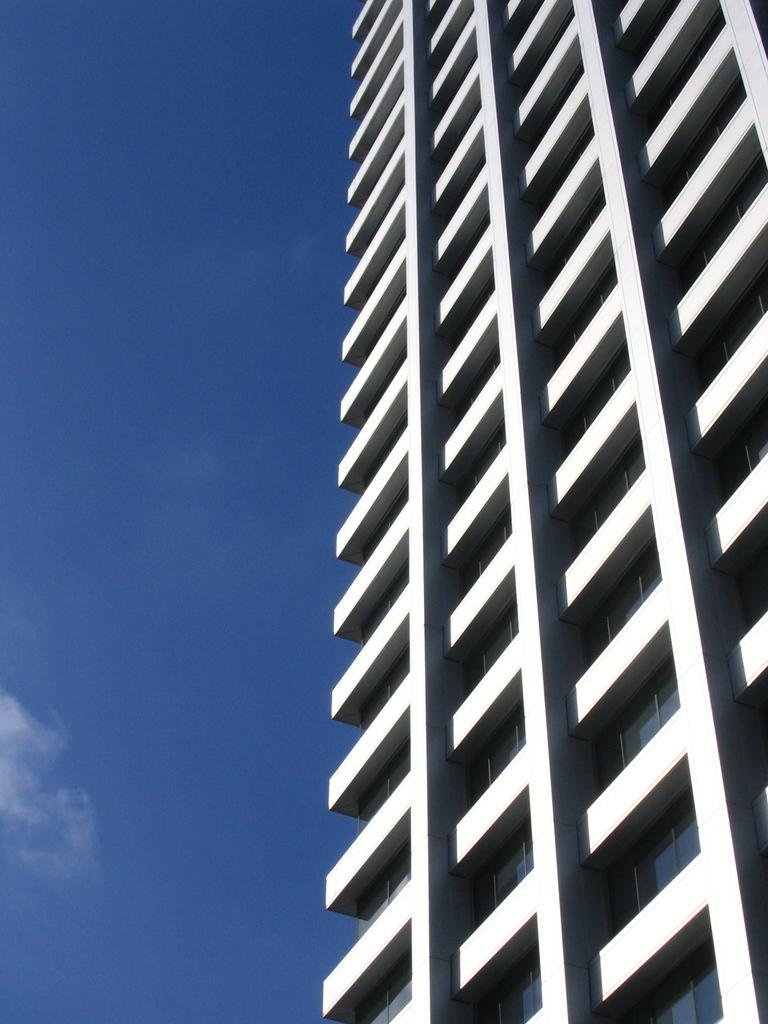What type of structure is the main subject of the image? There is a tall building in the image. How many floors does the building have? The building has multiple floors. What feature is common to each floor of the building? Each floor has glass windows or surfaces. What is visible at the top of the image? The sky is visible at the top of the image. What type of hat is the building wearing in the image? There is no hat present in the image, as the subject is a building. What type of lunch is being served on the top floor of the building in the image? There is no indication of any food or lunch being served in the image, as it primarily focuses on the building's structure and features. 